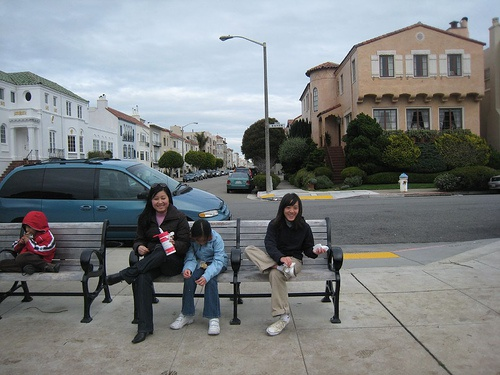Describe the objects in this image and their specific colors. I can see car in darkgray, black, blue, gray, and darkblue tones, bench in darkgray, gray, and black tones, bench in darkgray, gray, and black tones, people in darkgray, black, and gray tones, and people in darkgray, black, and gray tones in this image. 